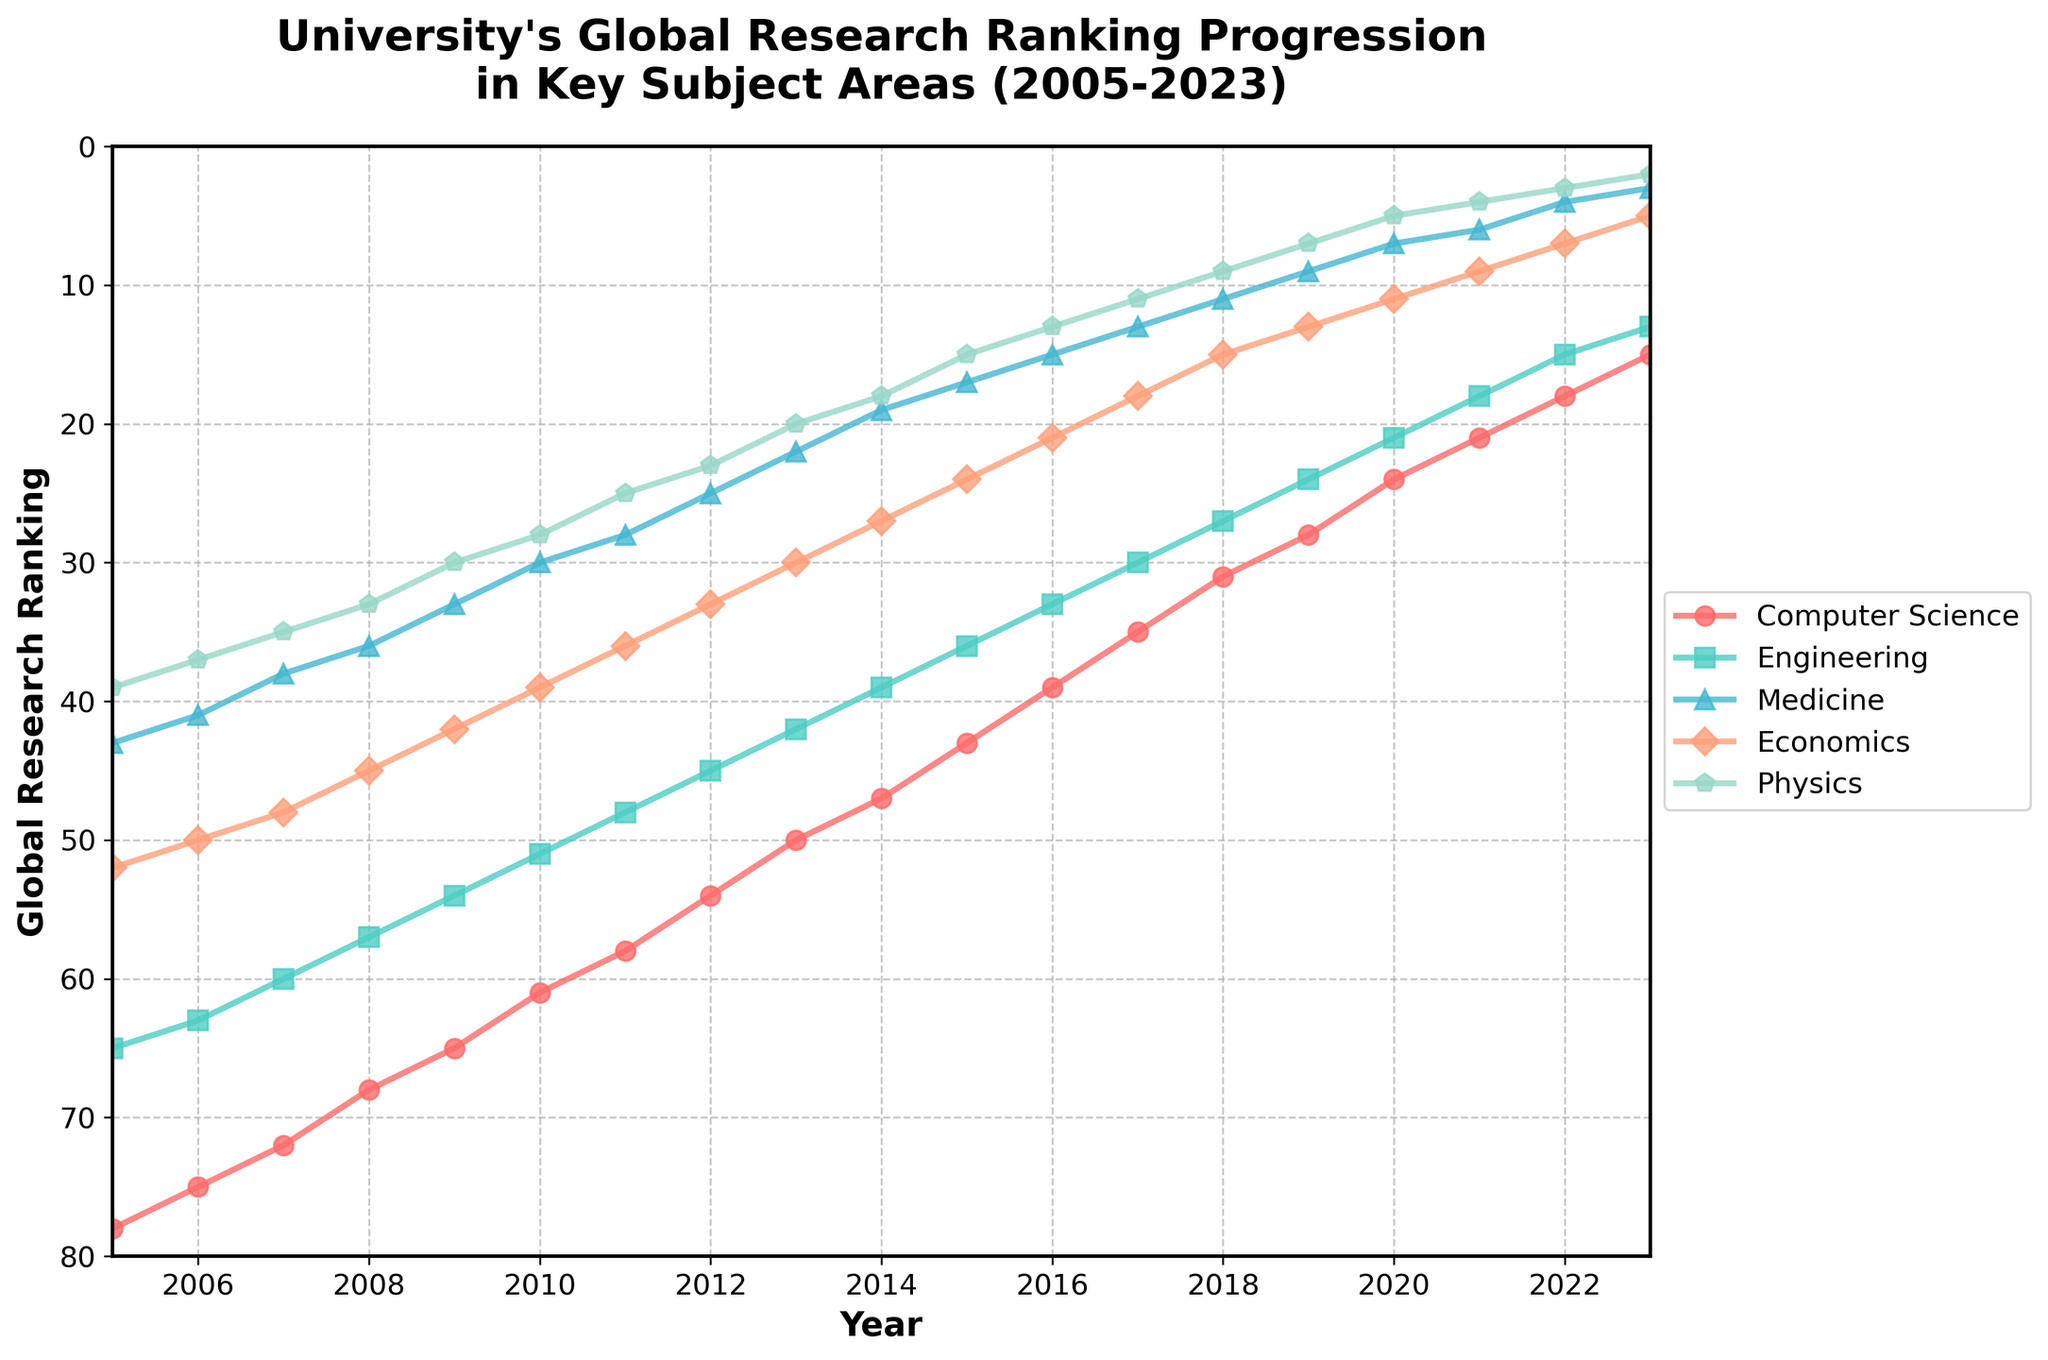What is the overall trend for the Computer Science ranking from 2005 to 2023? Observing the line representing Computer Science from 2005 to 2023, the ranking improves steadily. It starts at a higher ranking position in 2005 and reaches a much lower ranking position by 2023.
Answer: It improves consistently Which subject area had the highest ranking in 2005 and what was that ranking? By examining the values of different lines at the year 2005, the line for Physics has the lowest value, indicating the highest ranking.
Answer: Physics with a rank of 39 In what year did Medicine fall below a ranking of 10 for the first time? Focusing on the line for Medicine, it first dips below the ranking of 10 in the year 2019.
Answer: 2019 How much did the Economics ranking improve between 2005 and 2023? Checking the starting and ending values of the Economics line: ranking was 52 in 2005 and improved to 5 in 2023; thus, the improvement is 52 - 5.
Answer: 47 places Which two subject areas show a consistent improvement in rankings every year from 2005 to 2023? Inspecting the data lines for all subject areas, both Computer Science and Engineering lines show continuous improvement by moving downwards (higher ranks) every year without any plateau or increase.
Answer: Computer Science and Engineering On average, by how many places did the Medicine ranking improve each year from 2005 to 2023? Medicine improved from a rank of 43 in 2005 to 3 in 2023. The total improvement is 43 - 3 = 40 places over 18 years. Average yearly improvement is 40/18.
Answer: About 2.22 places per year In which year did Physics move below a ranking of 10 for the first time, and what was its ranking in that year? From the Physics line, it dips below the 10 mark in 2019, and its ranking in that year is 7.
Answer: 2019, with a rank of 7 Compare the rank improvement of Computer Science and Economics from 2005 to 2023. Which improved more? Computer Science improved from 78 to 15, an improvement of 78 - 15 = 63 places. Economics improved from 52 to 5, an improvement of 52 - 5 = 47 places. So, Computer Science improved more.
Answer: Computer Science improved more Which subject had the steepest decline in ranking between 2005 and 2010? Evaluating the steepness of lines between 2005 and 2010, Medicine's line shows the sharpest decline, moving from rank 43 to rank 30.
Answer: Medicine 